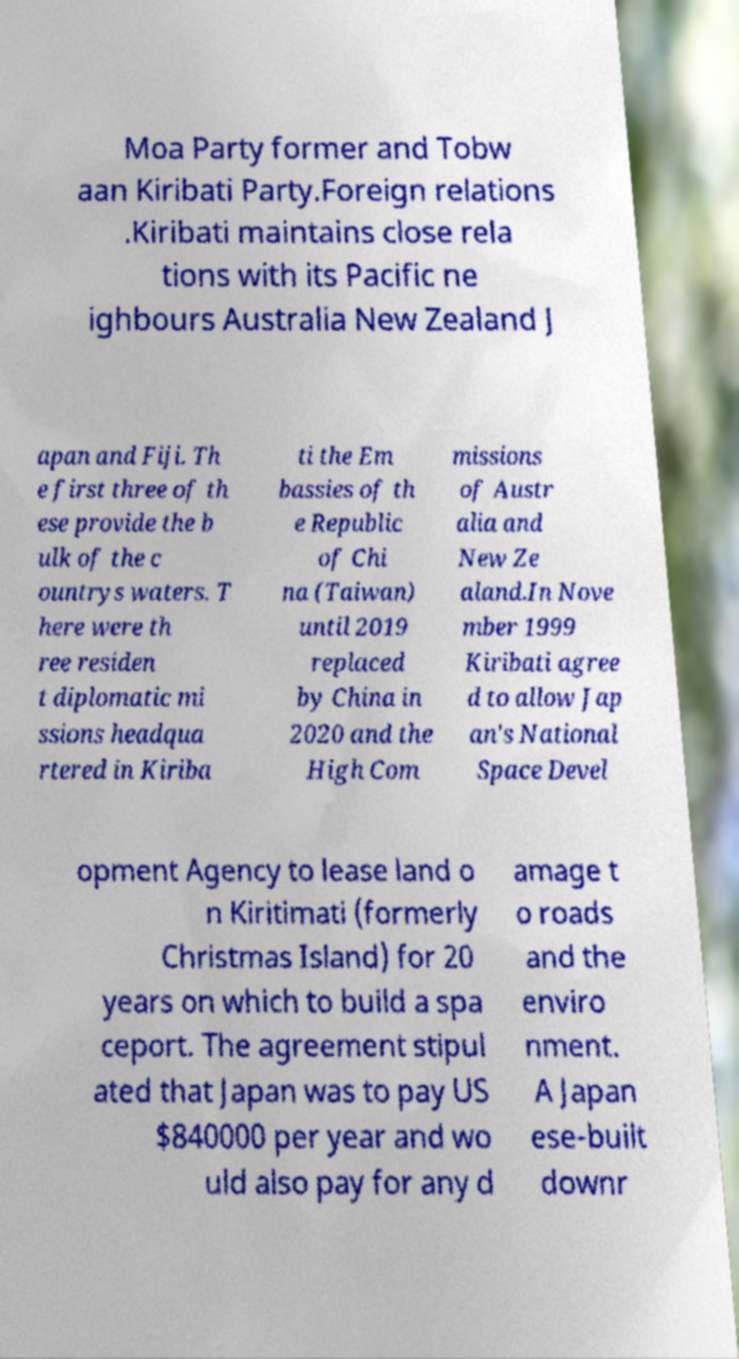Could you extract and type out the text from this image? Moa Party former and Tobw aan Kiribati Party.Foreign relations .Kiribati maintains close rela tions with its Pacific ne ighbours Australia New Zealand J apan and Fiji. Th e first three of th ese provide the b ulk of the c ountrys waters. T here were th ree residen t diplomatic mi ssions headqua rtered in Kiriba ti the Em bassies of th e Republic of Chi na (Taiwan) until 2019 replaced by China in 2020 and the High Com missions of Austr alia and New Ze aland.In Nove mber 1999 Kiribati agree d to allow Jap an's National Space Devel opment Agency to lease land o n Kiritimati (formerly Christmas Island) for 20 years on which to build a spa ceport. The agreement stipul ated that Japan was to pay US $840000 per year and wo uld also pay for any d amage t o roads and the enviro nment. A Japan ese-built downr 